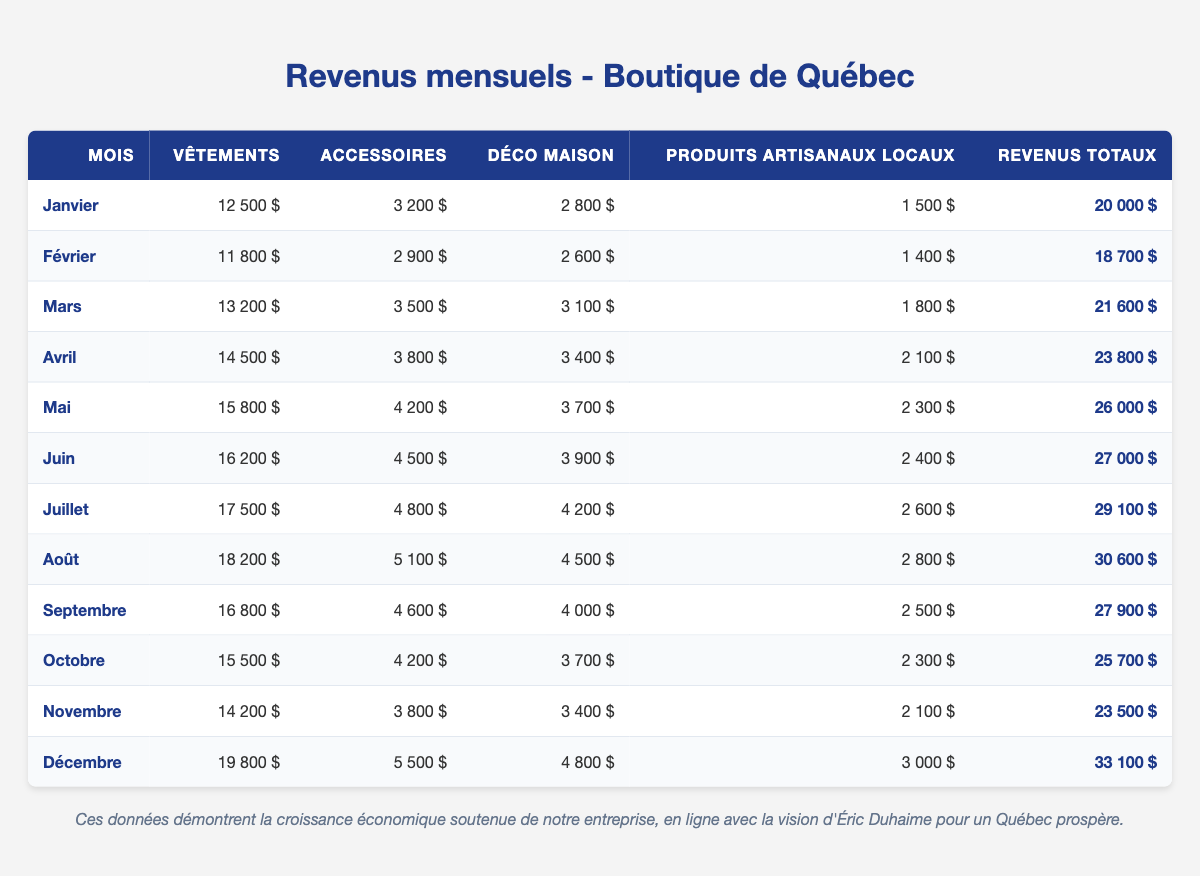What was the total revenue for December? In the table, we can find the row for December. The total revenue listed in that row is 33,100 dollars.
Answer: 33,100 dollars Which month had the highest revenue from clothing? Looking through the clothing column, January has 12,500 dollars, February 11,800 dollars, March 13,200 dollars, April 14,500 dollars, May 15,800 dollars, June 16,200 dollars, July 17,500 dollars, August 18,200 dollars, September 16,800 dollars, October 15,500 dollars, November 14,200 dollars, and December 19,800 dollars. The highest value is 19,800 dollars in December.
Answer: December What is the average revenue from accessories over the year? First, we sum all the accessory revenues: 3,200 + 2,900 + 3,500 + 3,800 + 4,200 + 4,500 + 4,800 + 5,100 + 4,600 + 4,200 + 3,800 + 5,500 = 4,500 dollars. Then we divide by the number of months (12): 54,500 / 12 = 4,541.67. Rounded, the average is approximately 4,542 dollars.
Answer: 4,542 dollars Did the revenue from local artisan goods ever exceed 3,000 dollars? By examining the local artisan goods column, we see the amounts: 1,500, 1,400, 1,800, 2,100, 2,300, 2,400, 2,600, 2,800, 2,500, 2,300, 2,100, and 3,000. The maximum value is 3,000 dollars, which means it did exceed it at least once.
Answer: Yes What month had the greatest increase in total revenue compared to the previous month? To determine the greatest increase, we can calculate the differences in total revenue for each consecutive month: (Février - Janvier), (Mars - Février), (Avril - Mars), (Mai - Avril), (Juin - Mai), (Juillet - Juin), (Août - Juillet), (Septembre - Août), (Octobre - Septembre), (Novembre - Octobre), (Décembre - Novembre). These differences are: -1,300, 2,900, 2,200, 3,200, 1,000, 2,100, 1,500, -2,700, -2,200, 1,600, 9,600. The greatest increase is 9,600 dollars from November to December.
Answer: December What was the total revenue in May and June combined? First, we find the total revenue for May, which is 26,000 dollars, and for June, which is 27,000 dollars. Then we add these two values: 26,000 + 27,000 = 53,000 dollars.
Answer: 53,000 dollars In which month was the revenue from home décor lower than 3,500 dollars? Looking at the home décor column, the values are 2,800, 2,600, 3,100, 3,400, 3,700, 3,900, 4,200, 4,500, 4,000, 3,700, 3,400, and 4,800. The months with revenue lower than 3,500 dollars are January, February, and April.
Answer: January and February Was the total revenue in August more than the total revenue received in January and February combined? The total revenue for August is 30,600 dollars. For January and February, we have 20,000 + 18,700 dollars = 38,700 dollars. Since 30,600 is less than 38,700, the answer is no.
Answer: No 